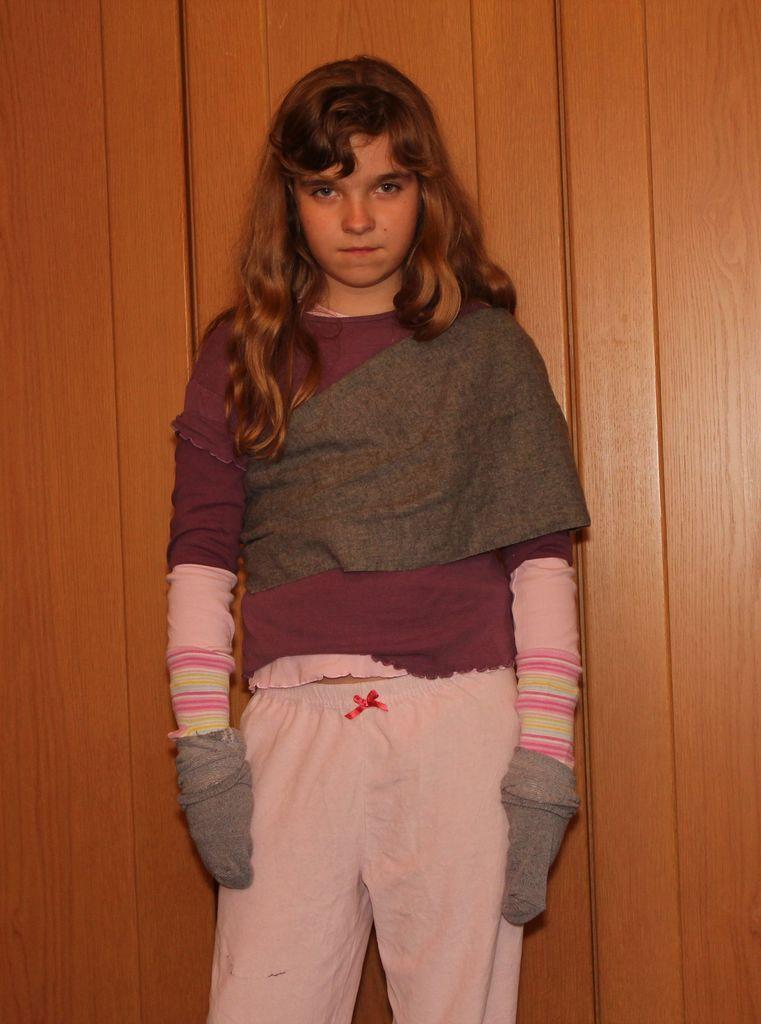What is the main subject of the image? There is a person standing in the image. Can you describe the background in the image? There is a background visible in the image. How many worms can be seen crawling on the person in the image? There are no worms present in the image; it only features a person standing and a background. 